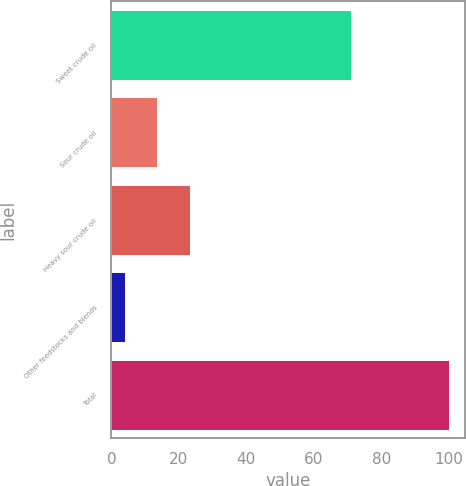<chart> <loc_0><loc_0><loc_500><loc_500><bar_chart><fcel>Sweet crude oil<fcel>Sour crude oil<fcel>Heavy sour crude oil<fcel>Other feedstocks and blends<fcel>Total<nl><fcel>71<fcel>13.6<fcel>23.2<fcel>4<fcel>100<nl></chart> 